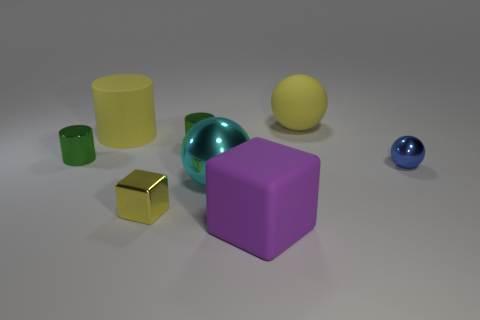Subtract all red cubes. Subtract all cyan balls. How many cubes are left? 2 Add 1 purple rubber cubes. How many objects exist? 9 Subtract all spheres. How many objects are left? 5 Add 1 large yellow metal things. How many large yellow metal things exist? 1 Subtract 0 red cylinders. How many objects are left? 8 Subtract all large spheres. Subtract all big purple things. How many objects are left? 5 Add 7 tiny blue metal objects. How many tiny blue metal objects are left? 8 